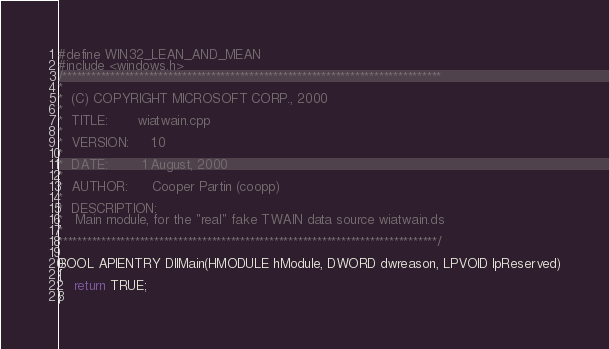<code> <loc_0><loc_0><loc_500><loc_500><_C++_>#define WIN32_LEAN_AND_MEAN
#include <windows.h>
/*******************************************************************************
*
*  (C) COPYRIGHT MICROSOFT CORP., 2000
*
*  TITLE:       wiatwain.cpp
*
*  VERSION:     1.0
*
*  DATE:        1 August, 2000
*
*  AUTHOR:      Cooper Partin (coopp)
*
*  DESCRIPTION:
*   Main module, for the "real" fake TWAIN data source wiatwain.ds
*
*******************************************************************************/

BOOL APIENTRY DllMain(HMODULE hModule, DWORD dwreason, LPVOID lpReserved)
{    
    return TRUE;
}

</code> 